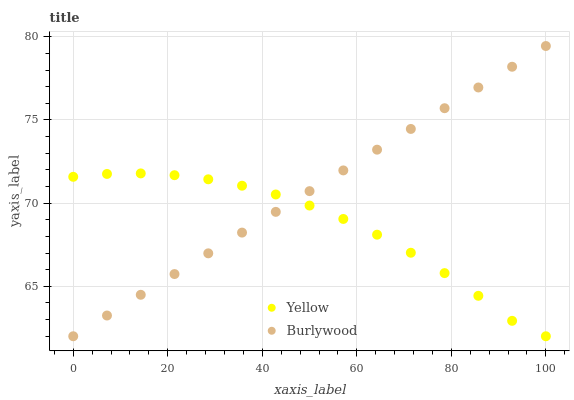Does Yellow have the minimum area under the curve?
Answer yes or no. Yes. Does Burlywood have the maximum area under the curve?
Answer yes or no. Yes. Does Yellow have the maximum area under the curve?
Answer yes or no. No. Is Burlywood the smoothest?
Answer yes or no. Yes. Is Yellow the roughest?
Answer yes or no. Yes. Is Yellow the smoothest?
Answer yes or no. No. Does Burlywood have the lowest value?
Answer yes or no. Yes. Does Burlywood have the highest value?
Answer yes or no. Yes. Does Yellow have the highest value?
Answer yes or no. No. Does Yellow intersect Burlywood?
Answer yes or no. Yes. Is Yellow less than Burlywood?
Answer yes or no. No. Is Yellow greater than Burlywood?
Answer yes or no. No. 